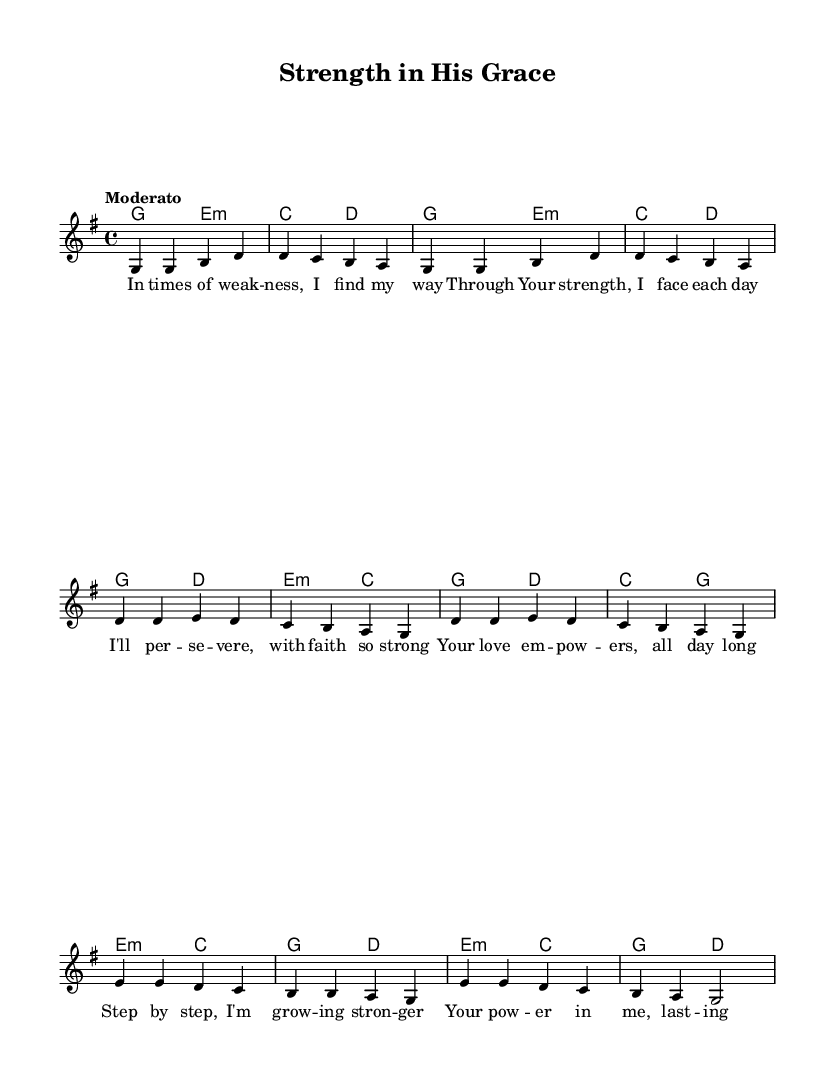What is the key signature of this music? The key signature is G major, which has one sharp (F#). This is determined by looking at the key signature at the beginning of the staff.
Answer: G major What is the time signature of this piece? The time signature is 4/4, which indicates that there are four beats in each measure and a quarter note gets one beat. This can be identified from the indication at the beginning of the staff.
Answer: 4/4 What is the tempo marking of the piece? The tempo marking is "Moderato", indicating a moderate speed for the piece. This can be found above the staff where the tempo is typically displayed.
Answer: Moderato How many measures are in the verse section? There are four measures in the verse section, as indicated by the grouping of notes before the transition to the chorus. Each line corresponds to a measure, and they are counted accordingly.
Answer: 4 What type of harmony is used in the bridge? The harmony used in the bridge is minor (E minor and C major), as seen in the chord changes listed in the harmony section that support the melody. The minor chords create a different emotional feel compared to major chords.
Answer: Minor What is the primary theme of the lyrics? The primary theme of the lyrics is strength and perseverance through faith, reflecting the message of relying on spiritual strength during challenging times. This is derived from the content and phrases presented in the lyrics.
Answer: Strength and perseverance 